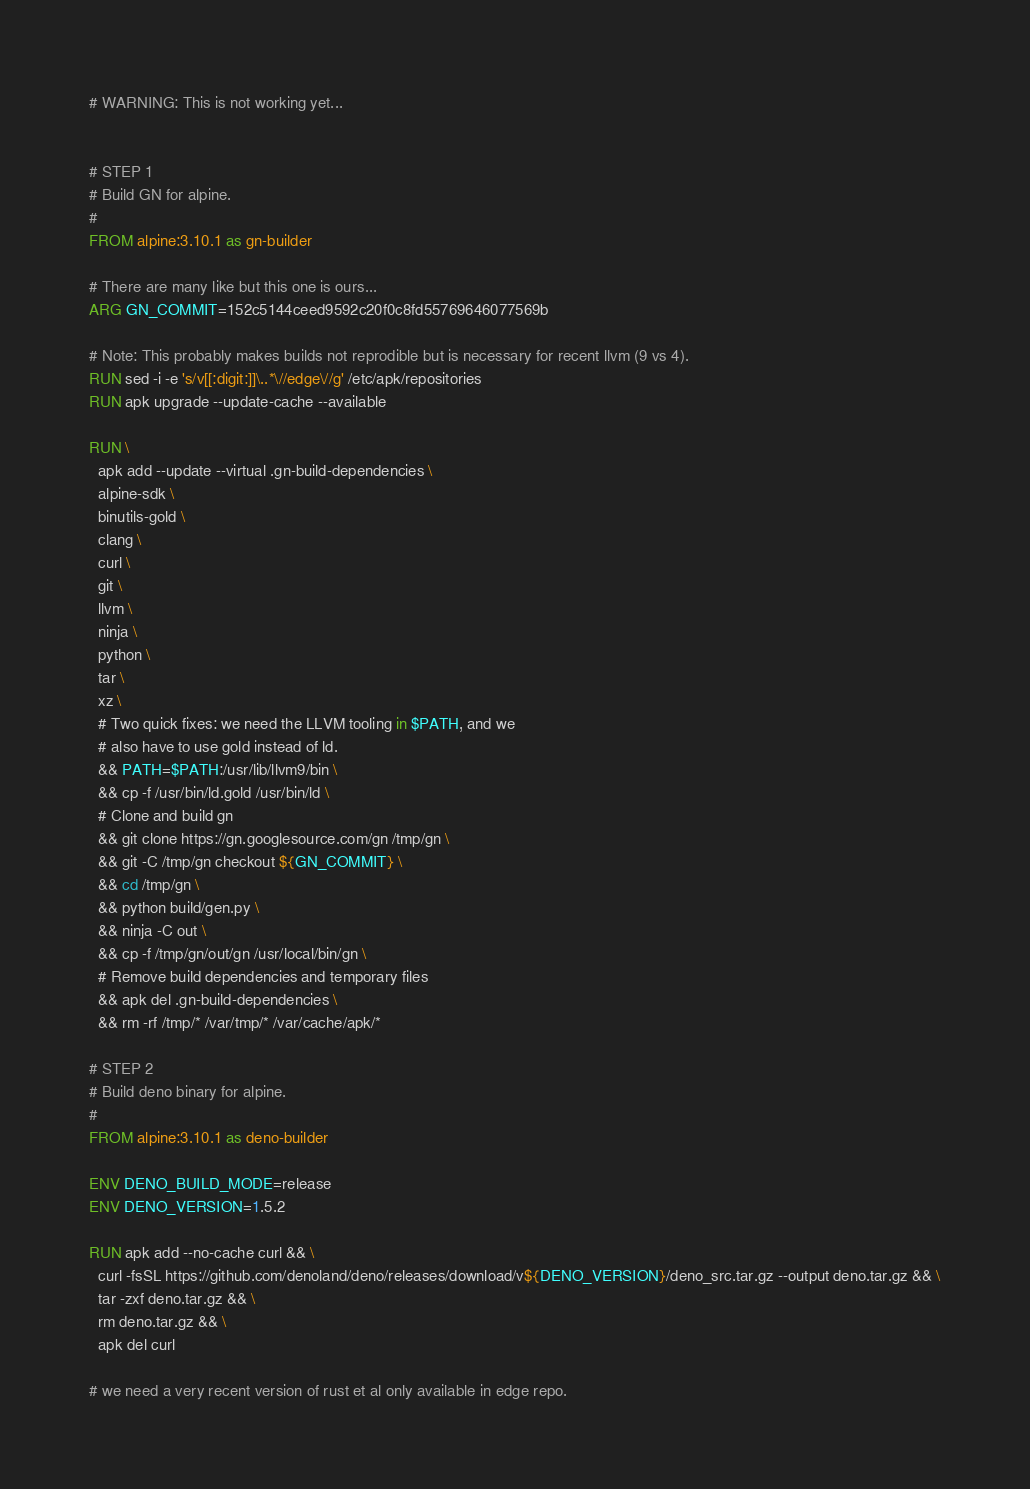Convert code to text. <code><loc_0><loc_0><loc_500><loc_500><_Dockerfile_># WARNING: This is not working yet...


# STEP 1
# Build GN for alpine.
#
FROM alpine:3.10.1 as gn-builder

# There are many like but this one is ours...
ARG GN_COMMIT=152c5144ceed9592c20f0c8fd55769646077569b

# Note: This probably makes builds not reprodible but is necessary for recent llvm (9 vs 4).
RUN sed -i -e 's/v[[:digit:]]\..*\//edge\//g' /etc/apk/repositories
RUN apk upgrade --update-cache --available

RUN \
  apk add --update --virtual .gn-build-dependencies \
  alpine-sdk \
  binutils-gold \
  clang \
  curl \
  git \
  llvm \
  ninja \
  python \
  tar \
  xz \
  # Two quick fixes: we need the LLVM tooling in $PATH, and we
  # also have to use gold instead of ld.
  && PATH=$PATH:/usr/lib/llvm9/bin \
  && cp -f /usr/bin/ld.gold /usr/bin/ld \
  # Clone and build gn
  && git clone https://gn.googlesource.com/gn /tmp/gn \
  && git -C /tmp/gn checkout ${GN_COMMIT} \
  && cd /tmp/gn \
  && python build/gen.py \
  && ninja -C out \
  && cp -f /tmp/gn/out/gn /usr/local/bin/gn \
  # Remove build dependencies and temporary files
  && apk del .gn-build-dependencies \
  && rm -rf /tmp/* /var/tmp/* /var/cache/apk/*

# STEP 2
# Build deno binary for alpine.
#
FROM alpine:3.10.1 as deno-builder

ENV DENO_BUILD_MODE=release
ENV DENO_VERSION=1.5.2

RUN apk add --no-cache curl && \
  curl -fsSL https://github.com/denoland/deno/releases/download/v${DENO_VERSION}/deno_src.tar.gz --output deno.tar.gz && \
  tar -zxf deno.tar.gz && \
  rm deno.tar.gz && \
  apk del curl

# we need a very recent version of rust et al only available in edge repo.</code> 